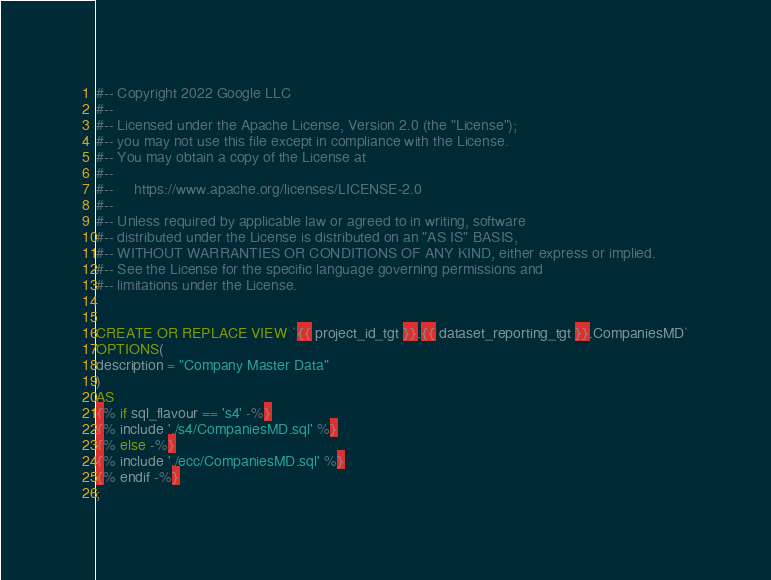<code> <loc_0><loc_0><loc_500><loc_500><_SQL_>#-- Copyright 2022 Google LLC
#--
#-- Licensed under the Apache License, Version 2.0 (the "License");
#-- you may not use this file except in compliance with the License.
#-- You may obtain a copy of the License at
#--
#--     https://www.apache.org/licenses/LICENSE-2.0
#--
#-- Unless required by applicable law or agreed to in writing, software
#-- distributed under the License is distributed on an "AS IS" BASIS,
#-- WITHOUT WARRANTIES OR CONDITIONS OF ANY KIND, either express or implied.
#-- See the License for the specific language governing permissions and
#-- limitations under the License.


CREATE OR REPLACE VIEW `{{ project_id_tgt }}.{{ dataset_reporting_tgt }}.CompaniesMD`
OPTIONS(
description = "Company Master Data"
)
AS
{% if sql_flavour == 's4' -%}
{% include './s4/CompaniesMD.sql' %}
{% else -%}
{% include './ecc/CompaniesMD.sql' %}
{% endif -%}
;
</code> 